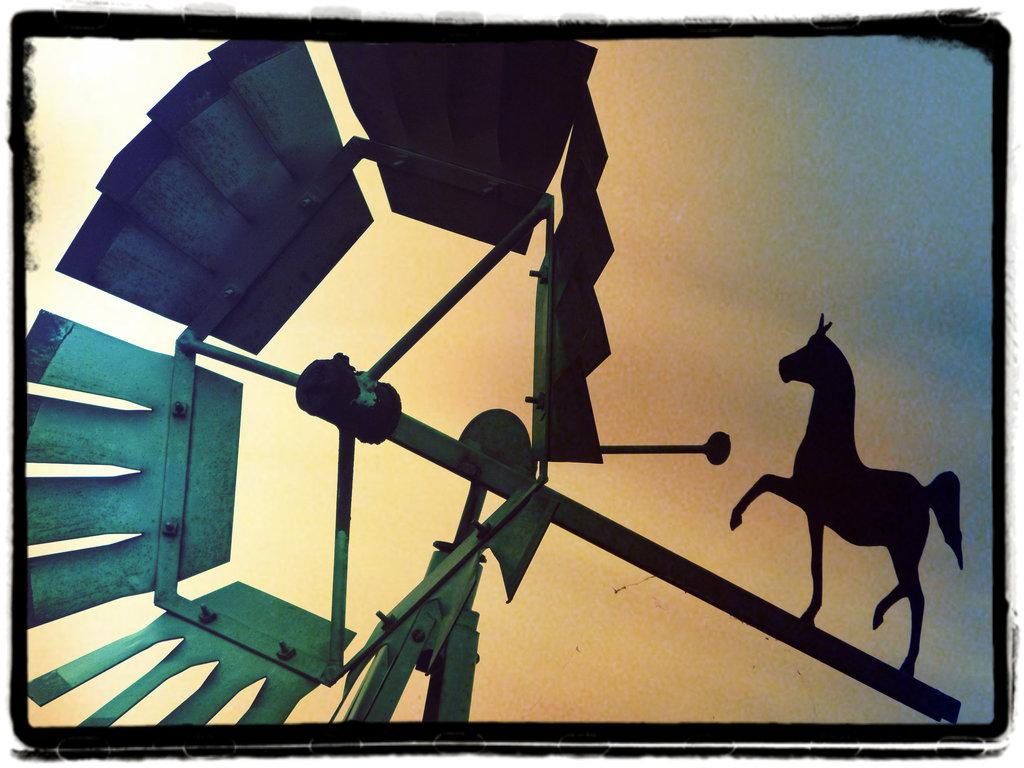What type of image is being described? The image appears to be animated. What animal can be seen on the right side of the image? There is a horse on the right side of the image. What type of object is present in the image? There is an iron object in the image. Can you describe the servant in the image? There is no servant present in the image. Is there a sink visible in the image? There is no sink present in the image. 